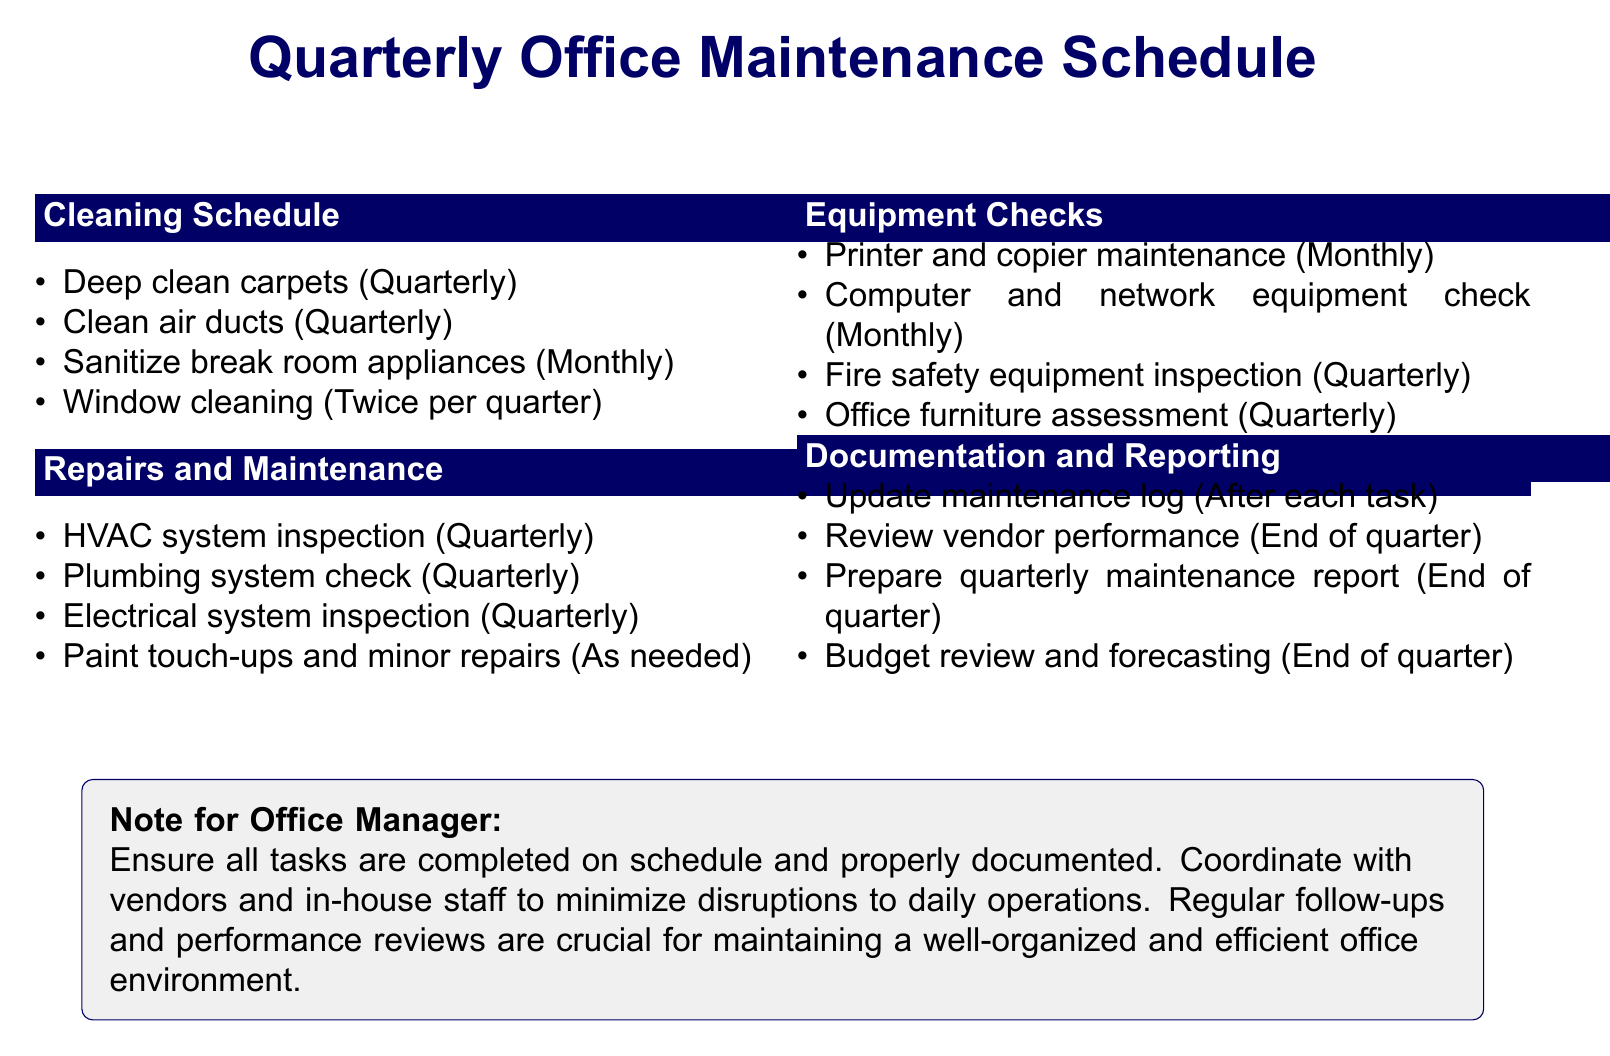What is the cleaning task assigned to ServiceMaster Clean? The document specifies that "Deep clean carpets" is assigned to ServiceMaster Clean.
Answer: Deep clean carpets How often is the air duct cleaning scheduled? According to the document, air duct cleaning occurs once per quarter.
Answer: Once per quarter Who is responsible for the inspection of fire safety equipment? FirePro Safety Services is the assigned vendor for the fire safety equipment inspection.
Answer: FirePro Safety Services What is the frequency of the office furniture assessment? The document indicates the office furniture assessment is done once per quarter.
Answer: Once per quarter How often are printer and copier maintenance tasks scheduled? Printer and copier maintenance is scheduled monthly according to the document.
Answer: Monthly Which team is tasked with budget review and forecasting? The office manager and Finance department are responsible for budget review and forecasting.
Answer: Office manager and Finance department What should the office manager do after each maintenance task? The office manager is instructed to update the maintenance log after each task.
Answer: Update maintenance log What is included in the monthly cleaning of break room appliances? The cleaning of break room appliances includes the refrigerator, microwave, and coffee machines.
Answer: Refrigerator, microwave, and coffee machines What is the primary goal of the quarterly maintenance report? The quarterly maintenance report summarizes completed tasks, issues encountered, and recommendations for improvement.
Answer: Summarize completed tasks, issues encountered, and recommendations for improvement 